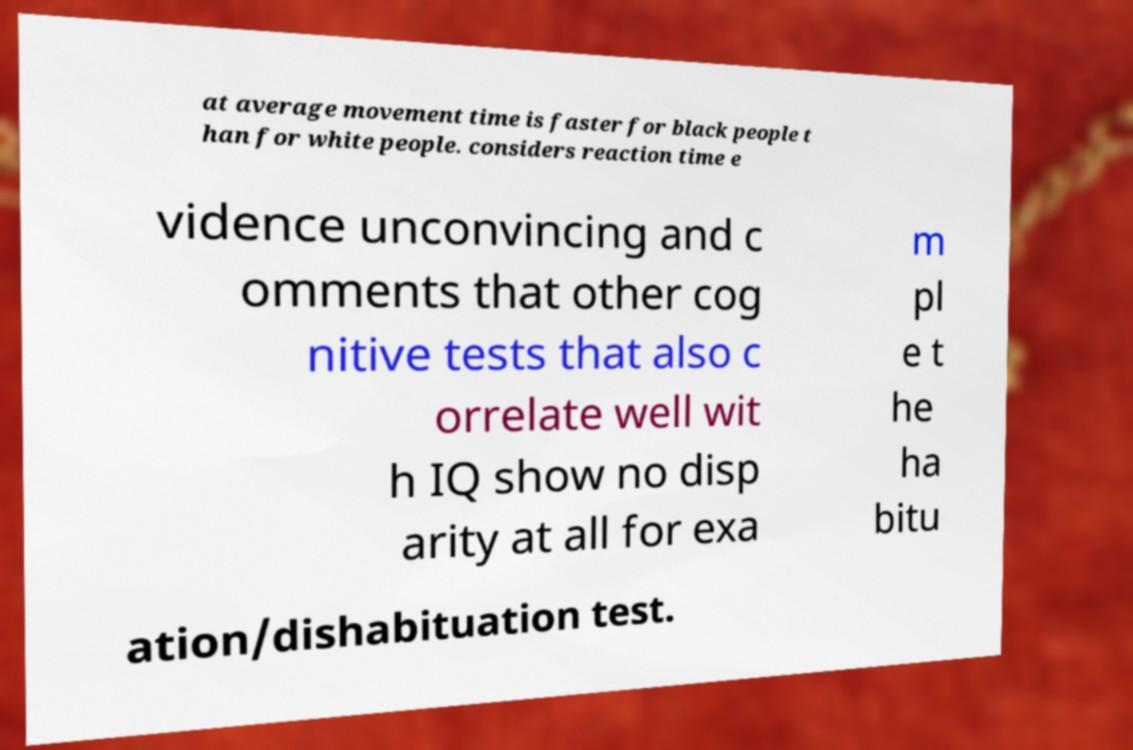What messages or text are displayed in this image? I need them in a readable, typed format. at average movement time is faster for black people t han for white people. considers reaction time e vidence unconvincing and c omments that other cog nitive tests that also c orrelate well wit h IQ show no disp arity at all for exa m pl e t he ha bitu ation/dishabituation test. 